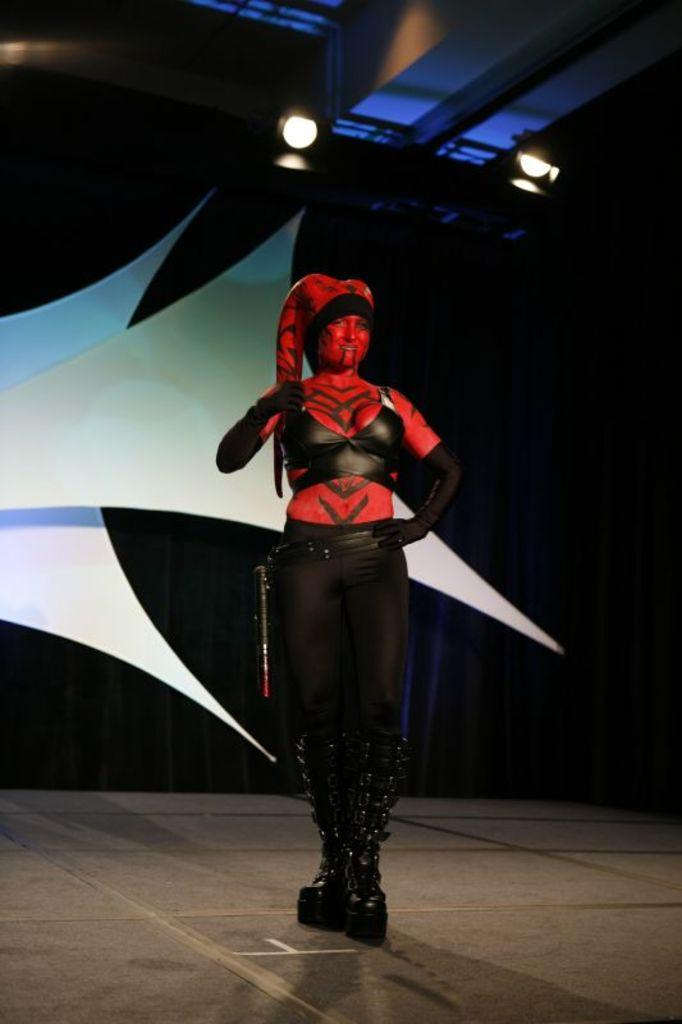Who is the main subject in the image? There is a woman in the image. Where is the woman located in the image? The woman is standing on a stage. What can be observed about the woman's appearance in the image? The woman is wearing makeup that resembles a devil. What type of vegetable is growing in the woman's hair in the image? There is no vegetable growing in the woman's hair in the image. What is the price of the woman's costume in the image? The image does not provide information about the price of the woman's costume. 